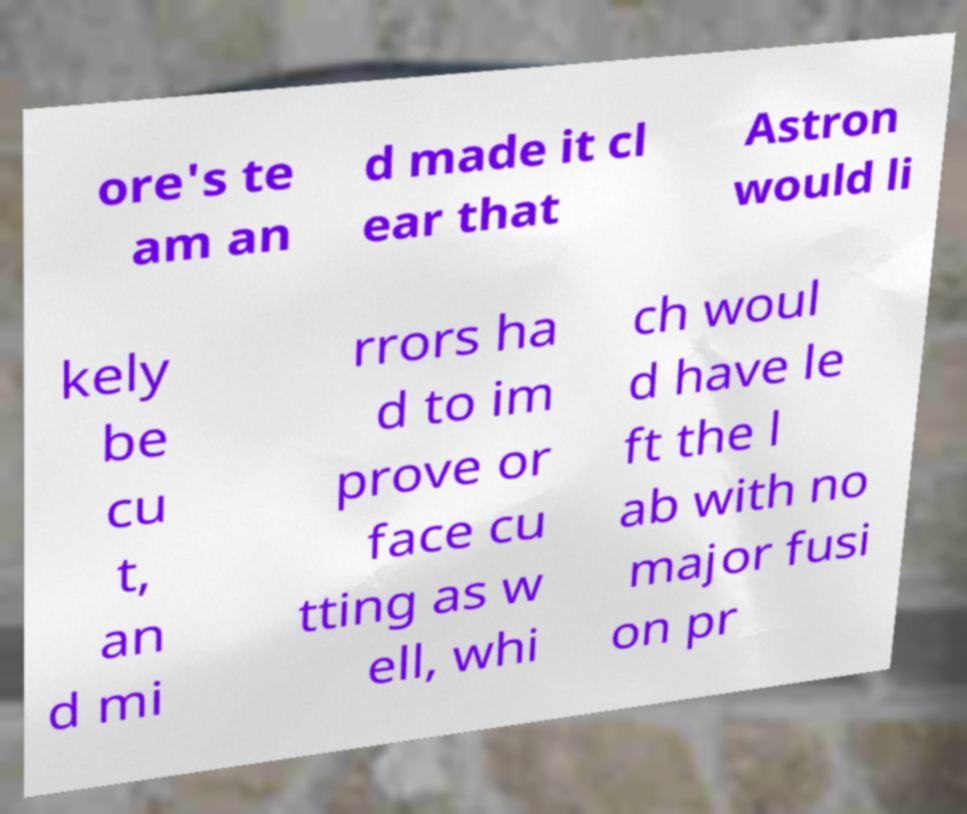For documentation purposes, I need the text within this image transcribed. Could you provide that? ore's te am an d made it cl ear that Astron would li kely be cu t, an d mi rrors ha d to im prove or face cu tting as w ell, whi ch woul d have le ft the l ab with no major fusi on pr 